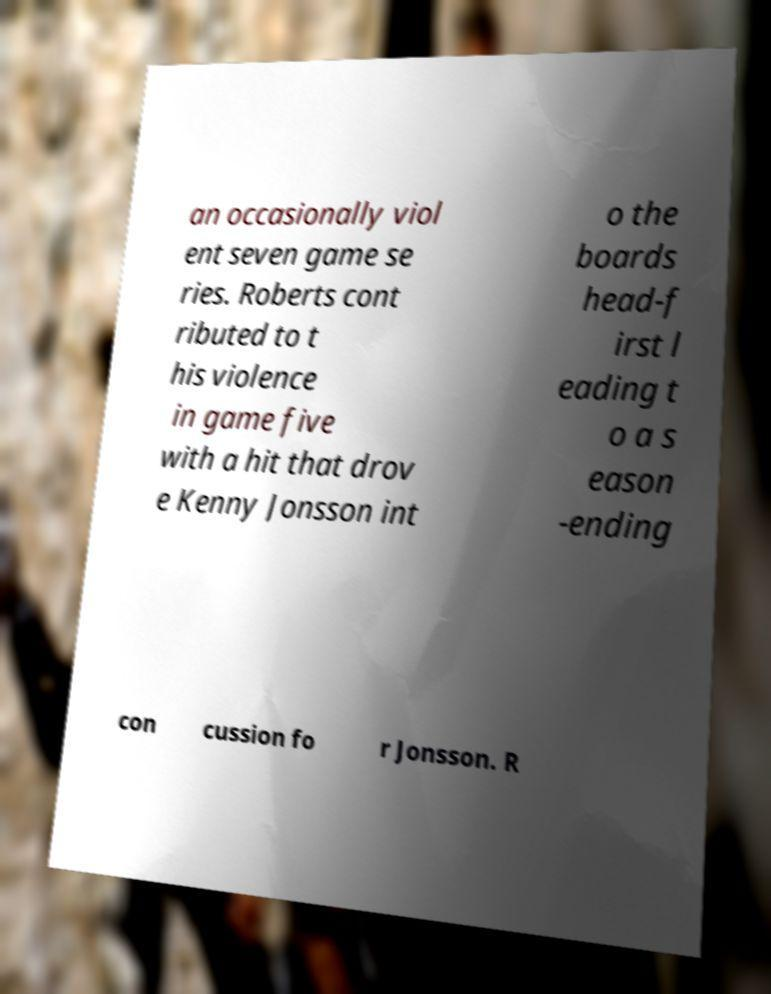Could you assist in decoding the text presented in this image and type it out clearly? an occasionally viol ent seven game se ries. Roberts cont ributed to t his violence in game five with a hit that drov e Kenny Jonsson int o the boards head-f irst l eading t o a s eason -ending con cussion fo r Jonsson. R 